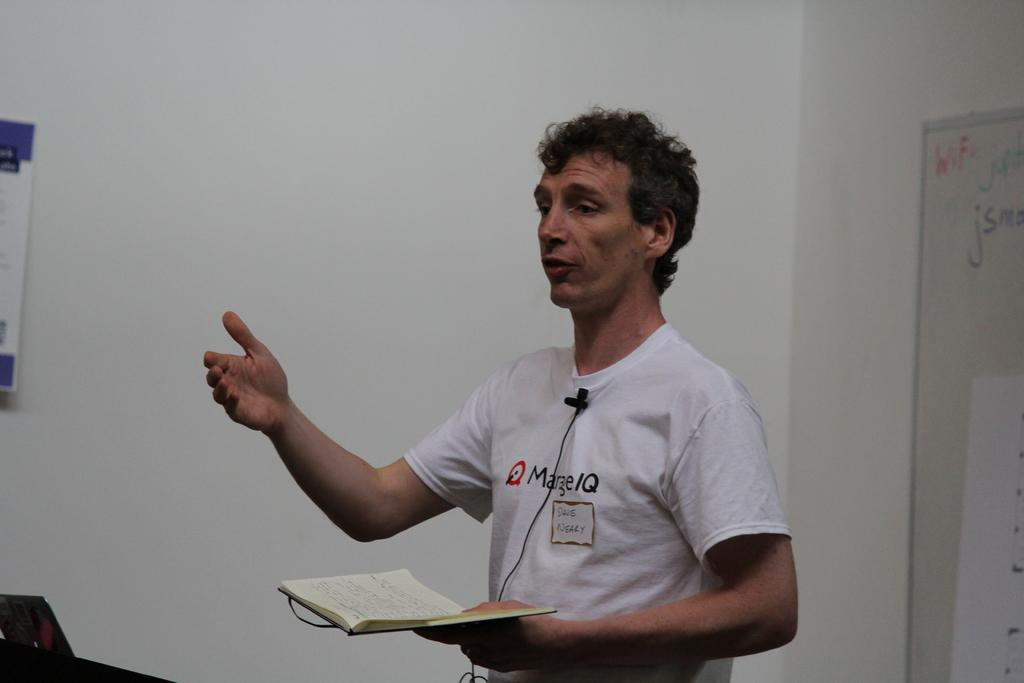Provide a one-sentence caption for the provided image. Man with a shirt saying Marge IQ giving a speech and holding a book. 